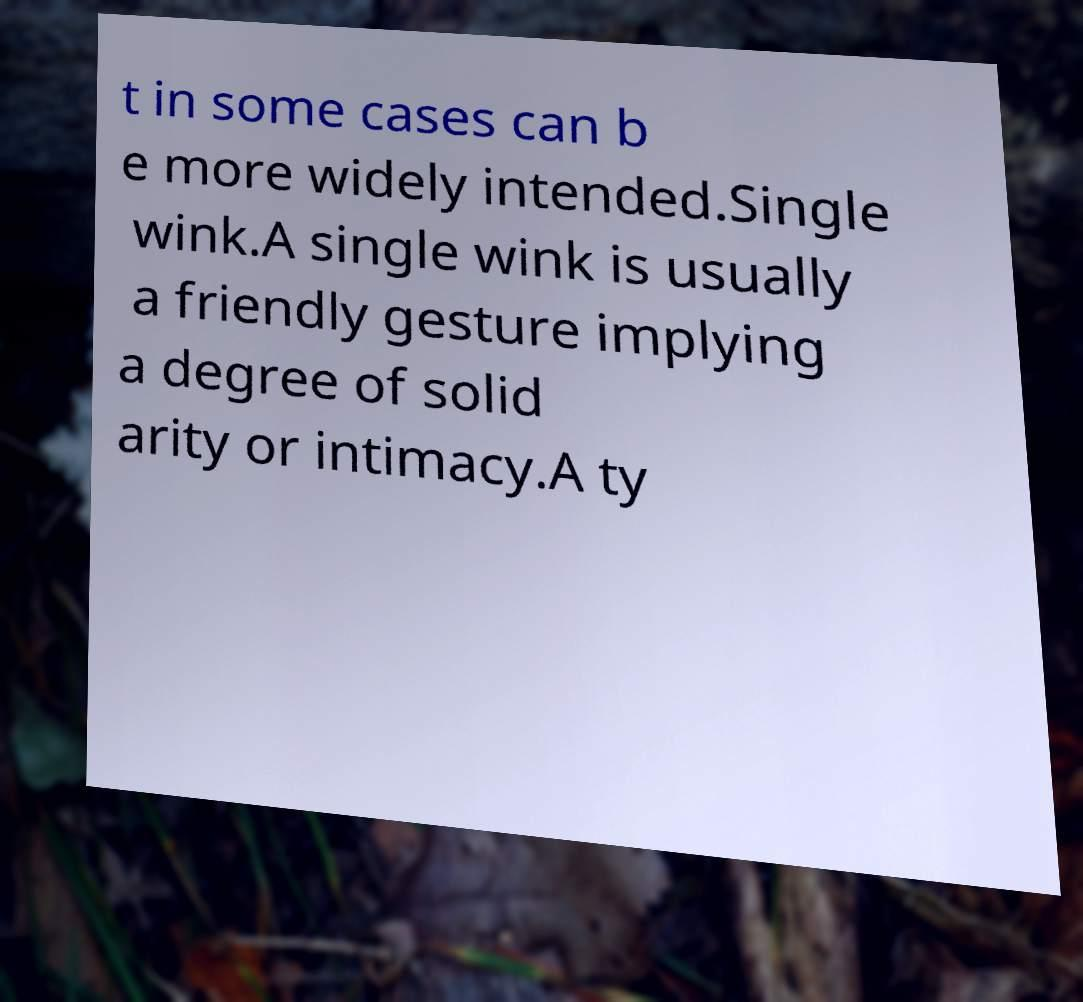Can you read and provide the text displayed in the image?This photo seems to have some interesting text. Can you extract and type it out for me? t in some cases can b e more widely intended.Single wink.A single wink is usually a friendly gesture implying a degree of solid arity or intimacy.A ty 